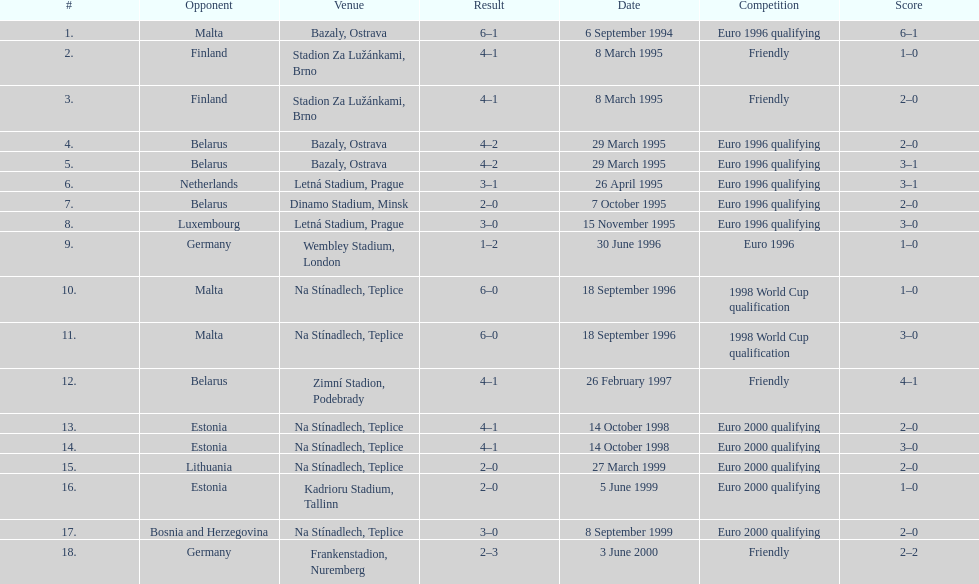While bazaly, ostrava was the venue on september 6, 1004, which place was used for the event on september 18, 1996? Na Stínadlech, Teplice. 